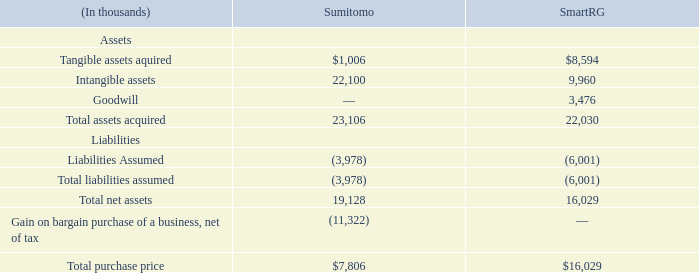Note 2 – Business Combinations
In November 2018, we acquired SmartRG, Inc., a provider of carrier-class, open-source connected home platforms and cloud services for broadband service providers for cash consideration. This transaction was accounted for as a business combination. We have included the financial results of this acquisition in our consolidated financial statements since the date of acquisition. These revenues are included in the Subscriber Solutions & Experience category within the Network Solutions and Services & Support reportable segments.
Contingent liabilities with a fair value totaling $1.2 million were recognized at the acquisition date, the payments of which were dependent upon SmartRG achieving future revenue, EBIT or customer purchase order milestones during the first half of 2019. The required milestones were not achieved and therefore, we recognized a gain of $1.2 million upon the reversal of these liabilities during the second quarter of 2019.
An escrow in the amount of $2.8 million was set up at the acquisition date to fund post-closing working capital settlements and to satisfy indemnity obligations to the Company arising from any inaccuracy or breach of representations, warranties, covenants, agreements or obligations of the sellers. The escrow is subject to arbitration. In December 2019, $1.3 million of the $2.8 million was released from the escrow account pursuant to the agreement, with the final settlement of the remaining balance expected during the fourth quarter of 2020. The remaining minimum and maximum potential release of funds to the seller ranges from no payment to $1.5 million.
We recorded goodwill of $3.5 million as a result of this acquisition, which represents the excess of the purchase price over the fair value of net assets acquired and liabilities assumed. We assessed the recognition and measurement of the assets acquired and liabilities assumed based on historical and forecasted data for future periods and concluded that our valuation procedures and resulting measures were appropriate.
On March 19, 2018, we acquired Sumitomo Electric Lightwave Corp.’s (SEL) North American EPON business and entered into a technology license and OEM supply agreement with Sumitomo Electric Industries, Ltd. (SEI). This acquisition establishes ADTRAN as the North American market leader for EPON solutions for the cable MSO industry and it will accelerate the MSO market’s adoption of our open, programmable and scalable architectures. This transaction was accounted for as a business combination. We have included the financial results of this acquisition in our consolidated financial statements since the date of acquisition. These revenues are included in the Access & Aggregation and Subscriber Solutions & Experience categories within the Network Solutions reportable segment.
We recorded a bargain purchase gain of $11.3 million during the first quarter of 2018, net of income taxes, which is subject to customary working capital adjustments between the parties. The bargain purchase gain of $11.3 million represents the difference between the fair-value of the net assets acquired over the cash paid. SEI, an OEM supplier based in Japan, is the global market leader in EPON. SEI’s Broadband Networks Division, through its SEL subsidiary, operated a North American EPON business that included sales, marketing, support, and region-specific engineering development. The North American EPON market is primarily driven by the Tier 1 cable MSO operators and has developed more slowly than anticipated. Through the transaction, SEI divested its North American EPON assets and established a relationship with ADTRAN. The transfer of these assets to ADTRAN, which included key customer relationships and a required assumption by ADTRAN of relatively low incremental expenses, along with the value of the technology license and OEM supply agreement, resulted in the bargain purchase gain. We have assessed the recognition and measurement of the assets acquired and liabilities assumed based on historical and forecasted data for future periods and we have concluded that our valuation procedures and resulting measures were appropriate. The gain is included in the line item ”Gain on bargain purchase of a business” in the 2018 Consolidated Statements of Income.
The final allocation of the purchase price to the estimated fair value of the assets acquired and liabilities assumed at the acquisition date for SmartRG and the final allocation of the purchase price to the estimated fair value of the assets acquired and liabilities assumed at the acquisition date for Sumitomo are as follows:
(In thousands)
What kind of service did SmartRG, Inc. provide? Carrier-class, open-source connected home platforms and cloud services for broadband service providers for cash consideration. What was the tangible assets aquired from Sumitomo?
Answer scale should be: thousand. 1,006. How much were the intangible assets from SmartRG?
Answer scale should be: thousand. 9,960. What was the difference in tangible assets acquired between Sumitomo and SmartRG?
Answer scale should be: thousand. $8,594-$1,006
Answer: 7588. What was the difference in total purchase price between Sumitomo and SmartRG?
Answer scale should be: thousand. $16,029-$7,806
Answer: 8223. What is the total net assets of SmartRG as a ratio of the total net assets of Sumitomo? 16,029/19,128
Answer: 0.84. 